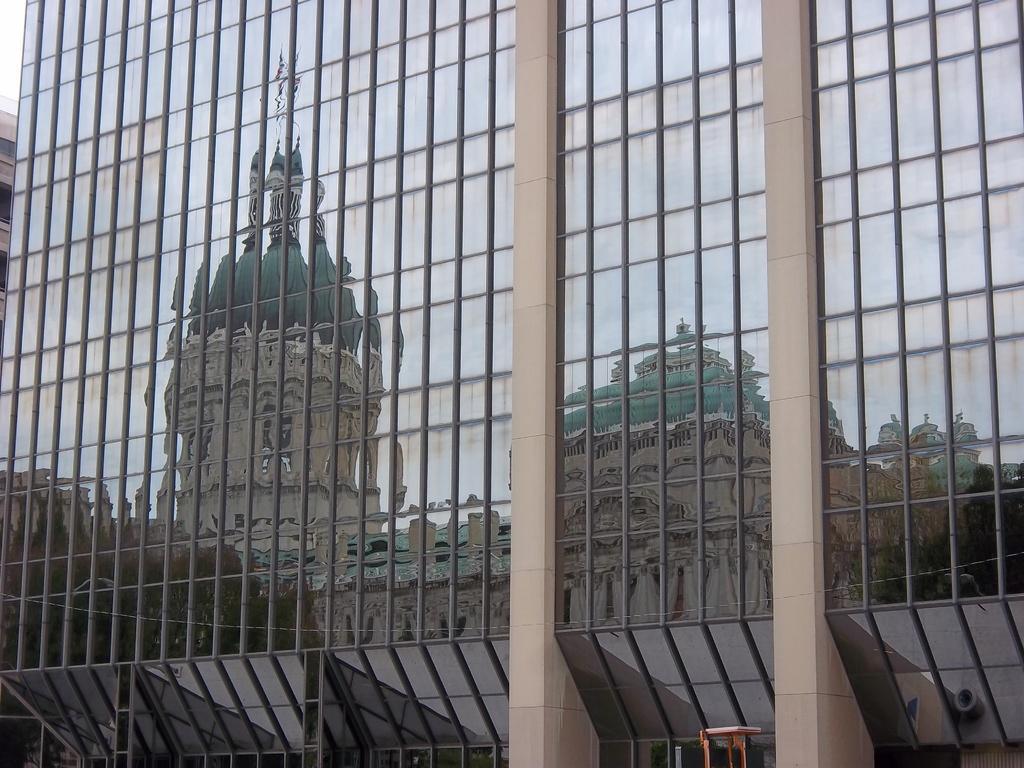Could you give a brief overview of what you see in this image? In the center of the image we can see one glass building and a few other objects. And we can see one building reflection on the glass. On the left side of the image, we can see one more building and windows. 